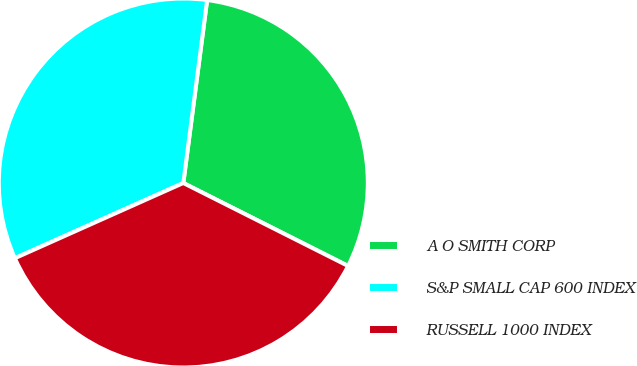Convert chart to OTSL. <chart><loc_0><loc_0><loc_500><loc_500><pie_chart><fcel>A O SMITH CORP<fcel>S&P SMALL CAP 600 INDEX<fcel>RUSSELL 1000 INDEX<nl><fcel>30.36%<fcel>33.74%<fcel>35.89%<nl></chart> 